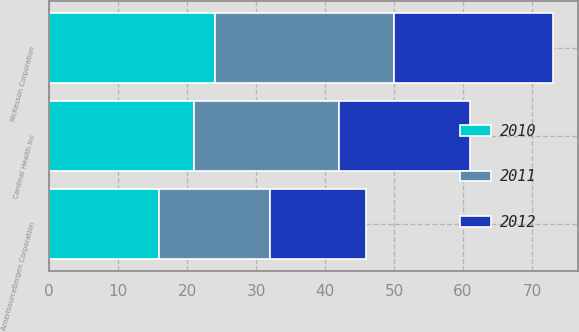Convert chart to OTSL. <chart><loc_0><loc_0><loc_500><loc_500><stacked_bar_chart><ecel><fcel>McKesson Corporation<fcel>Cardinal Health Inc<fcel>AmerisourceBergen Corporation<nl><fcel>2012<fcel>23<fcel>19<fcel>14<nl><fcel>2011<fcel>26<fcel>21<fcel>16<nl><fcel>2010<fcel>24<fcel>21<fcel>16<nl></chart> 